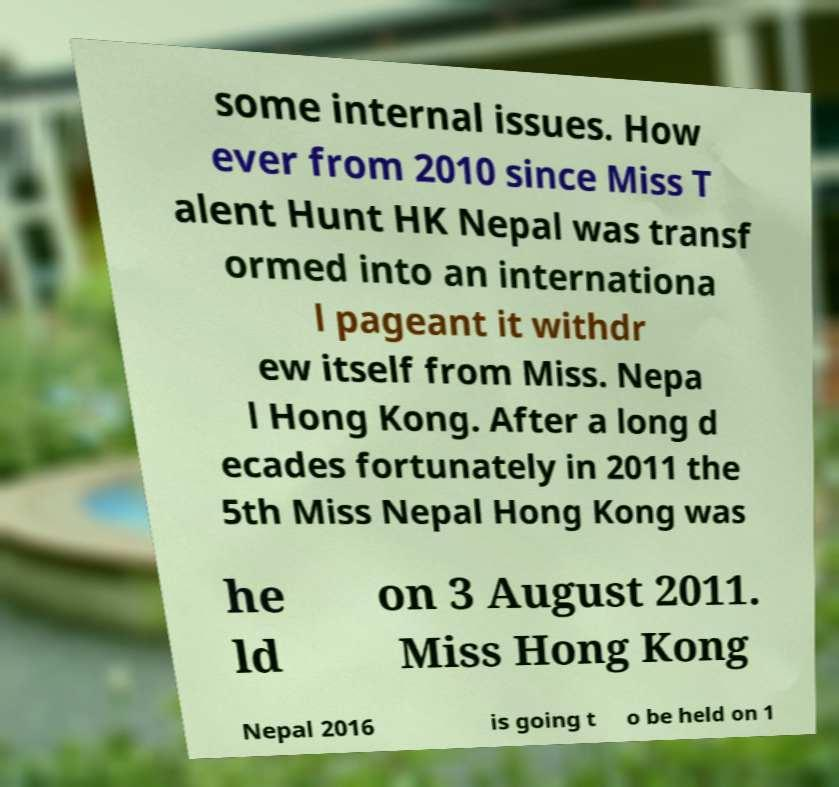For documentation purposes, I need the text within this image transcribed. Could you provide that? some internal issues. How ever from 2010 since Miss T alent Hunt HK Nepal was transf ormed into an internationa l pageant it withdr ew itself from Miss. Nepa l Hong Kong. After a long d ecades fortunately in 2011 the 5th Miss Nepal Hong Kong was he ld on 3 August 2011. Miss Hong Kong Nepal 2016 is going t o be held on 1 